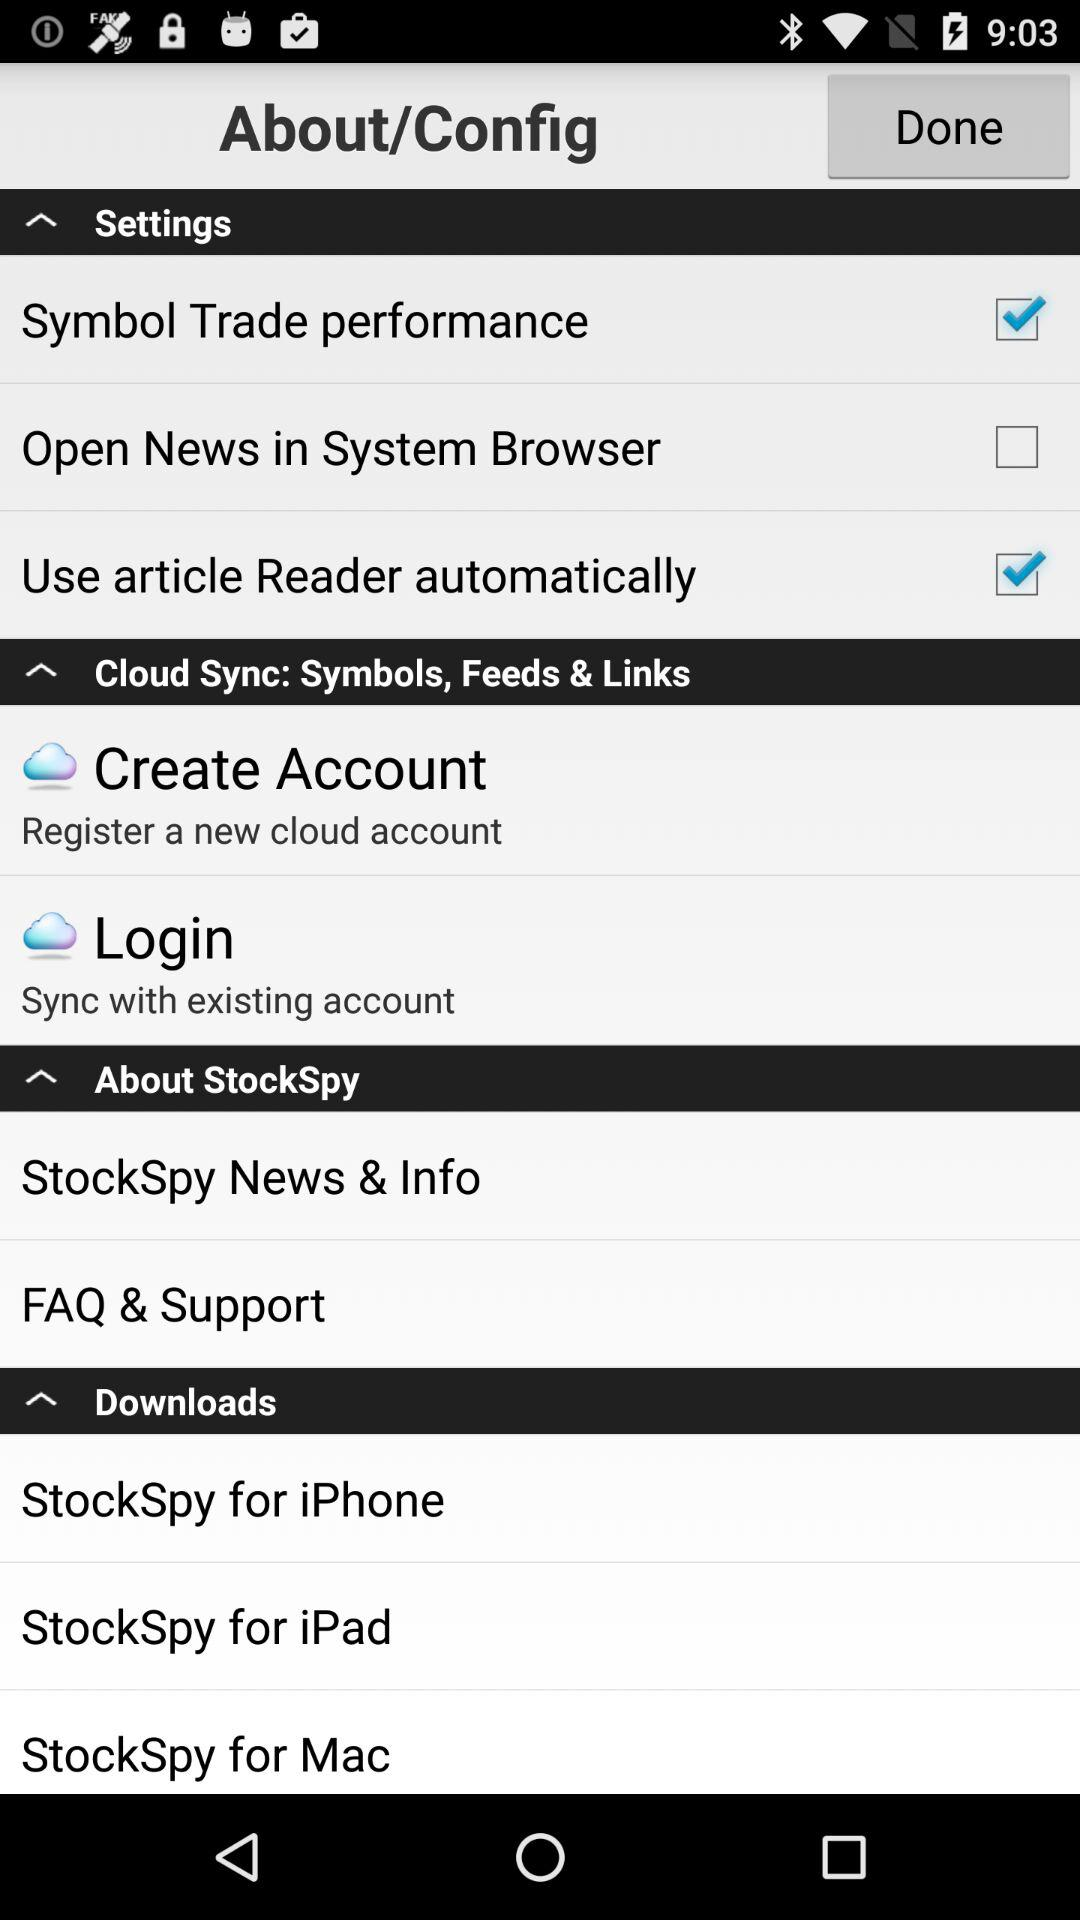What is the status of the "Use article Reader automatically"? The status is "on". 